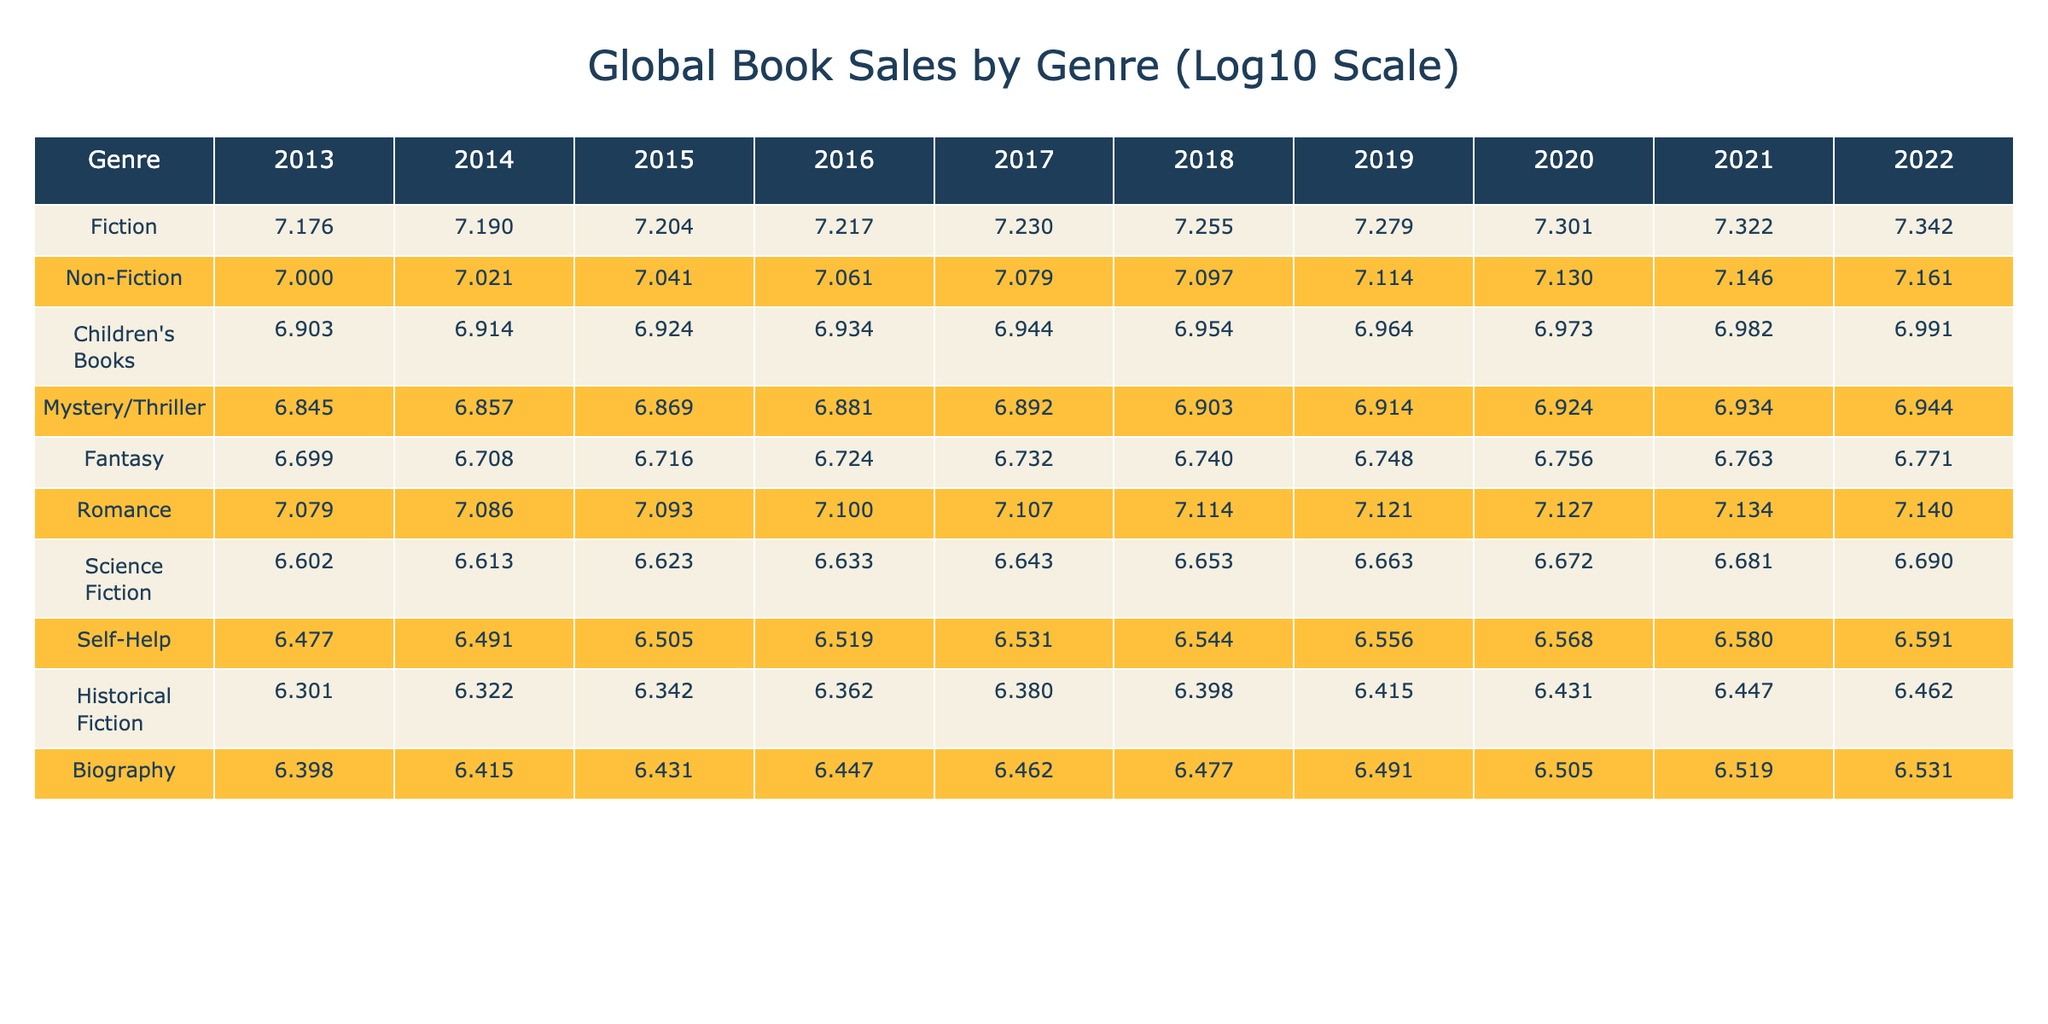What were the book sales for Fiction in 2020? Looking at the row for Fiction, the value listed under the year 2020 is 4.301.
Answer: 4.301 Which genre had the highest sales in 2022? The highest sales in 2022 can be found by comparing all the values in that row. The highest value is for Fiction, which is 4.343.
Answer: 4.343 What is the difference in sales between Non-Fiction in 2013 and 2022? The sales for Non-Fiction in 2013 is 4.000 and in 2022 is 4.162. To find the difference, we subtract 4.000 from 4.162, resulting in 0.162.
Answer: 0.162 Did Children's Books sales increase every year over the past decade? By examining the values for Children's Books from 2013 to 2022, we see a continual upward trend each year, indicating an increase every year.
Answer: Yes What is the average sales value for Romance over the decade? To calculate the average, we sum the values from 2013 (4.079) to 2022 (4.140), which gives us 4.079 + 4.084 + 4.090 + 4.096 + 4.103 + 4.107 + 4.110 + 4.113 + 4.116 + 4.119 = 40.9, divided by 10 (number of years) gives us 4.090.
Answer: 4.090 Which genre showed the smallest increase in sales from 2013 to 2022? Comparing the increases from 2013 to 2022 for each genre, Historical Fiction increased from 3.301 in 2013 to 4.462 in 2022, which is the smallest increase compared to others.
Answer: Historical Fiction What were the Children's Books sales in 2016, and how did it compare to 2021? In 2016, Children's Books sales were 4.934, and in 2021, the sales were 4.983. This indicates a growth of 0.049 when comparing the two years.
Answer: 4.934 (2021: 4.983) How did Science Fiction sales in 2015 compare to the overall average sales value across all genres in that year? The Science Fiction sales for 2015 is 3.623, and if we calculate the average for all genres in 2015, it’s much higher at 4.183. Science Fiction's sales were lower than the average.
Answer: Lower In which year did Fantasy exceed 5 million in sales for the first time? By checking the values for Fantasy, we see that it first exceeded 5 million in 2016 with the logarithmic value of 3.7241.
Answer: 2016 